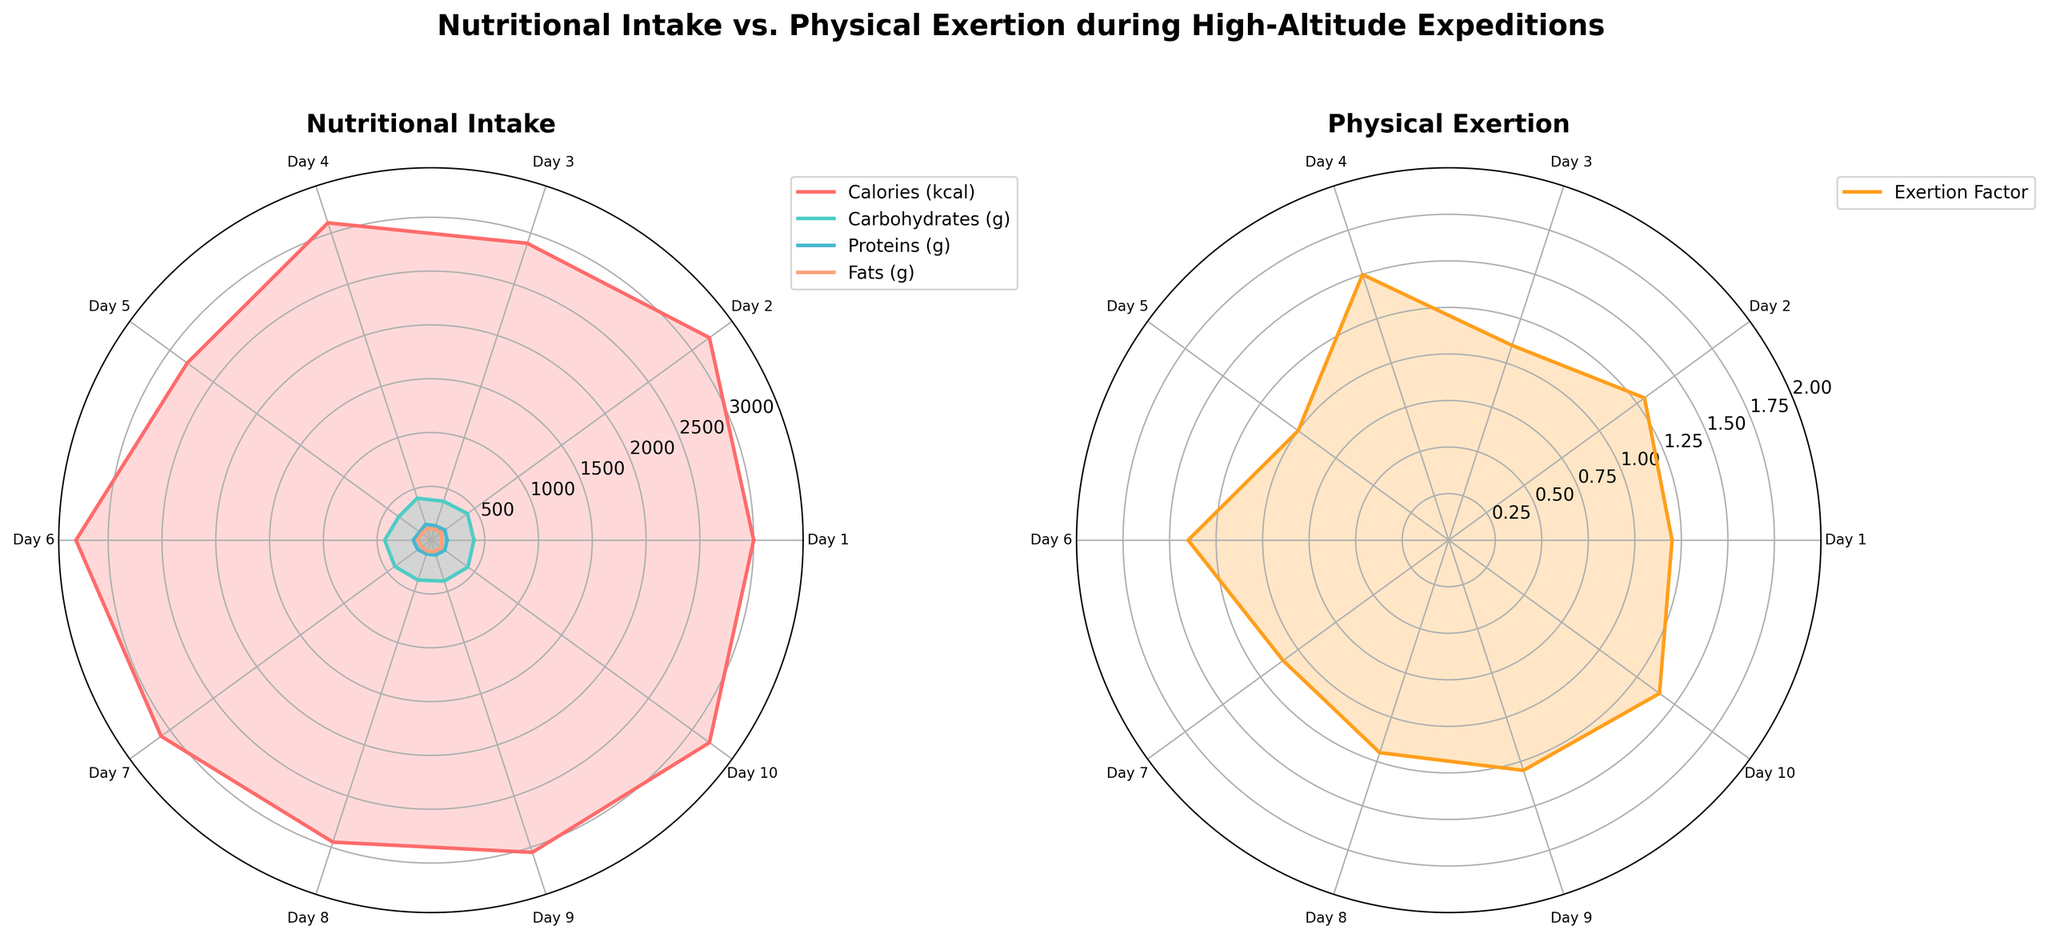What is the title of the figure? The title of the figure is displayed prominently at the top: "Nutritional Intake vs. Physical Exertion during High-Altitude Expeditions".
Answer: Nutritional Intake vs. Physical Exertion during High-Altitude Expeditions What color represents the 'Calories (kcal)' in the nutritional intake subplot? The 'Calories (kcal)' are represented by a reddish color in the nutritional intake subplot.
Answer: Red How many days of data are presented in the plots? By counting the number of ticks on the angular axis of either of the polar plots, we see that there are 10 days represented.
Answer: 10 Which subplot depicts the 'Exertion Factor'? There are two subplots; the one on the right with the label "Physical Exertion" depicts the 'Exertion Factor'.
Answer: Right On which day is the 'Exertion Factor' the highest, and what value does it reach? The highest 'Exertion Factor' value is indicated by the peak point closest to the outer edge of the plot, and it occurs on Day 4, reaching a value of 1.5.
Answer: Day 4, 1.5 What is the 'Exertion Factor' on Day 9? Look at the corresponding tick label for Day 9 on the right subplot (Physical Exertion) and trace the value from the center to the plotted line. It shows the value of 1.3.
Answer: 1.3 Compare the 'Proteins (g)' intake between Day 2 and Day 5. Which day has a higher intake and by how much? By tracing the protein levels on the left polar plot from the tick labels for Day 2 and Day 5, we find Day 2 has 160g and Day 5 has 130g of proteins. The difference is 160g - 130g = 30g.
Answer: Day 2, 30g What was the overall trend for 'Carbohydrates (g)' from Day 1 to Day 10? Observing the 'Carbohydrates (g)' progression in the left subplot, we notice fluctuations, with notable peaks on Days 2, 4, 6, and 10, and comparatively lower values on Days 3 and 5.
Answer: Fluctuations with peaks on Days 2, 4, 6, and 10 Which day had the lowest caloric intake? By examining the direction and distance of each plotted point for 'Calories (kcal)' on the left subplot, we see that Day 5 has the smallest distance from the center, indicating the lowest caloric intake of 2800 kcal.
Answer: Day 5 How does the pattern of 'Fats (g)' intake compare to the 'Exertion Factor'? By comparing the left and right subplot patterns visually, we can observe that both peaks for 'Fats (g)' and 'Exertion Factor' share days with high values, such as Days 2, 4, 6, and 10, indicating a roughly aligning trend.
Answer: Roughly aligning trend 